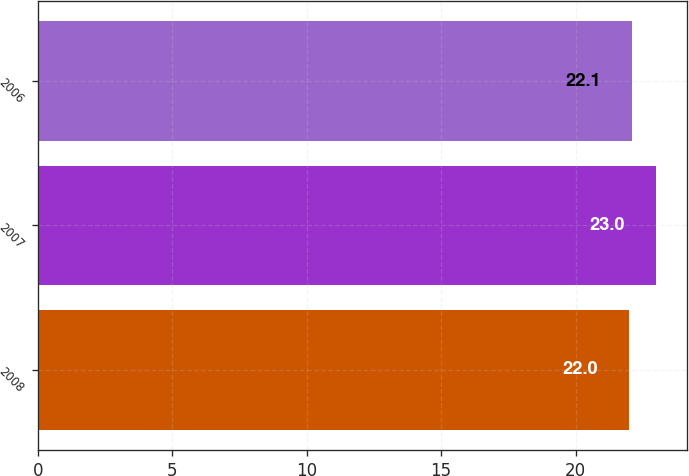Convert chart. <chart><loc_0><loc_0><loc_500><loc_500><bar_chart><fcel>2008<fcel>2007<fcel>2006<nl><fcel>22<fcel>23<fcel>22.1<nl></chart> 